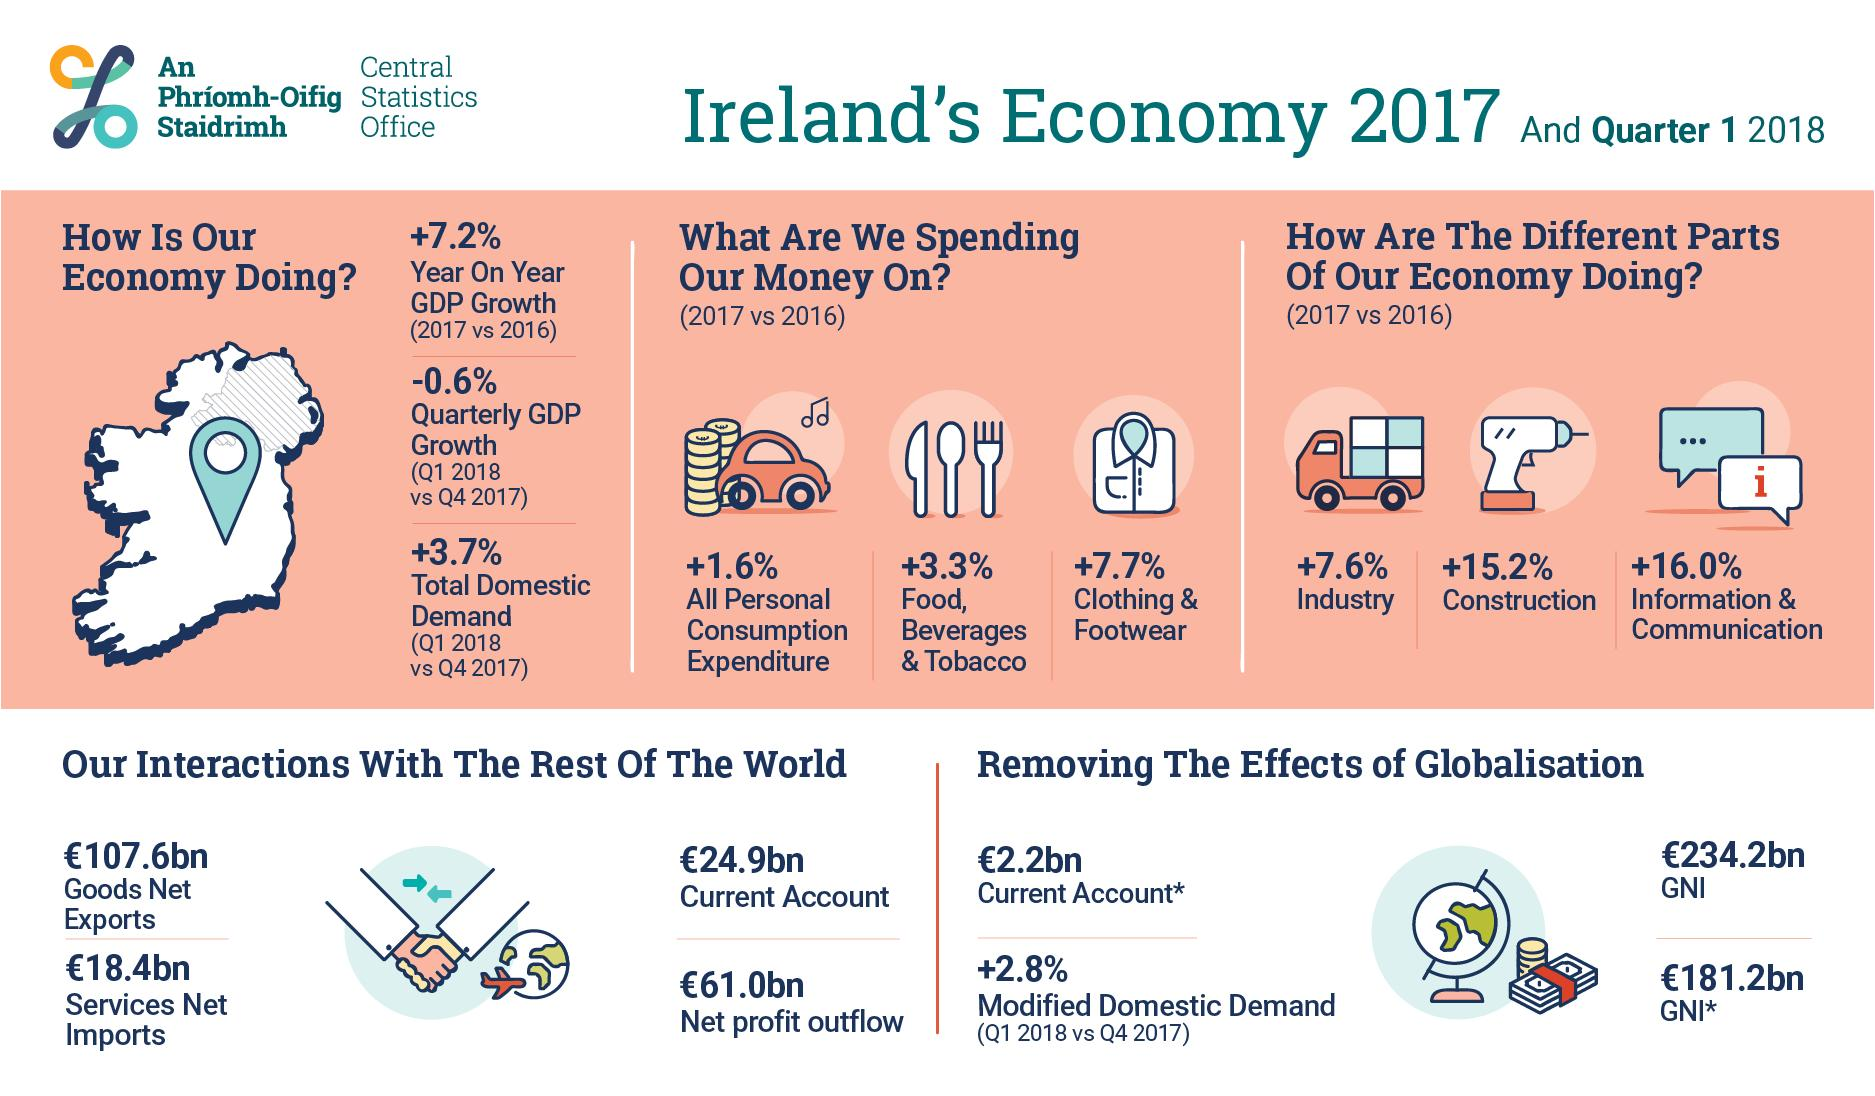Indicate a few pertinent items in this graphic. The expenditure in the construction sector has increased by 15.2%. Personal consumption expenditure has increased by 1.6% from 2016 to 2017. The spending on clothes and footwear has increased by 7.7% from 2016. The spending on the industry sector in 2016 has increased by 7.6% compared to the previous year. The Gross Domestic Product (GDP) increased by 7.2% in 2017 compared to 2016. 